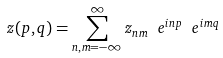<formula> <loc_0><loc_0><loc_500><loc_500>z ( p , q ) = \sum _ { n , m = - \infty } ^ { \infty } z _ { n m } \ e ^ { i n p } \ e ^ { i m q }</formula> 